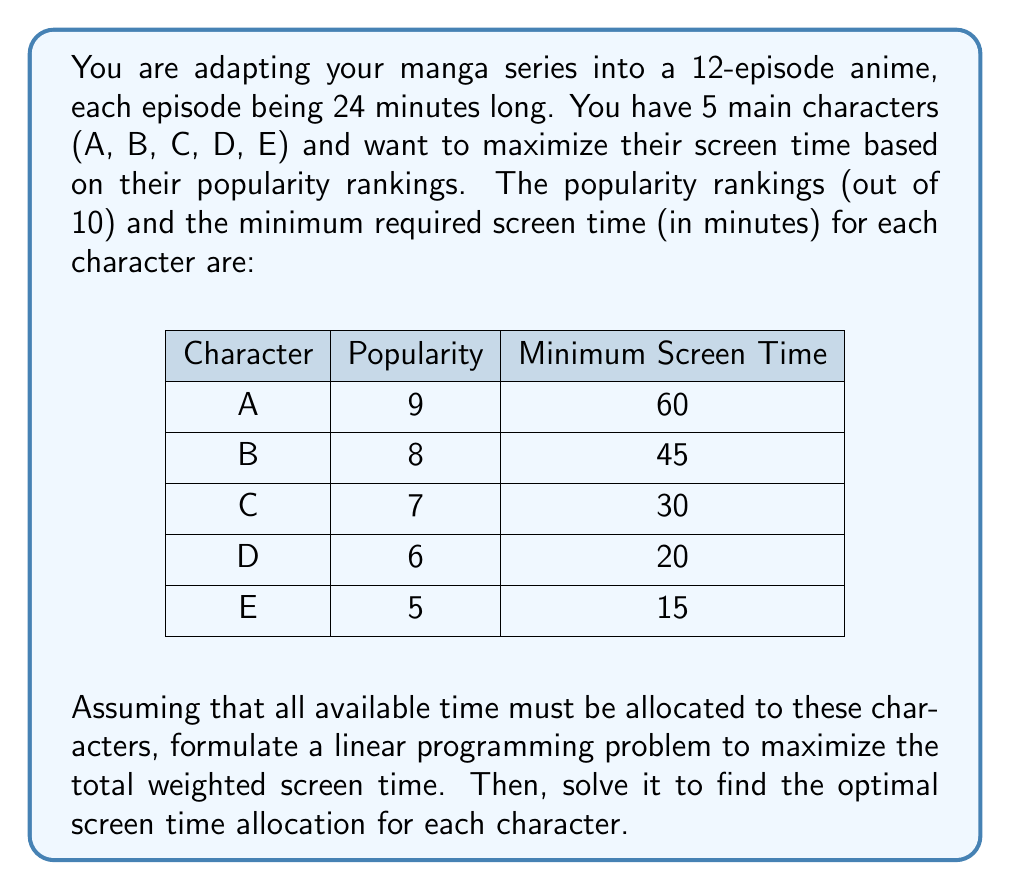Can you solve this math problem? To solve this problem, we'll use linear programming. Let's define our variables and constraints:

Variables:
$x_A, x_B, x_C, x_D, x_E$ = screen time for characters A, B, C, D, and E respectively

Objective function:
Maximize $Z = 9x_A + 8x_B + 7x_C + 6x_D + 5x_E$

Constraints:
1. Total available time: $x_A + x_B + x_C + x_D + x_E = 12 \cdot 24 = 288$ minutes
2. Minimum screen time for each character:
   $x_A \geq 60$
   $x_B \geq 45$
   $x_C \geq 30$
   $x_D \geq 20$
   $x_E \geq 15$
3. Non-negativity: $x_A, x_B, x_C, x_D, x_E \geq 0$

To solve this, we'll use the simplex method:

1. Convert to standard form:
   Maximize $Z = 9x_A + 8x_B + 7x_C + 6x_D + 5x_E$
   Subject to:
   $x_A + x_B + x_C + x_D + x_E = 288$
   $x_A - s_A = 60$
   $x_B - s_B = 45$
   $x_C - s_C = 30$
   $x_D - s_D = 20$
   $x_E - s_E = 15$
   All variables $\geq 0$

2. Initial basic feasible solution:
   $x_A = 60, x_B = 45, x_C = 30, x_D = 20, x_E = 15, s_A = 0, s_B = 0, s_C = 0, s_D = 0, s_E = 0$
   Slack in total time: $288 - (60 + 45 + 30 + 20 + 15) = 118$

3. Optimize:
   The highest coefficient in the objective function is 9 for $x_A$, so we increase $x_A$.
   $x_A$ can be increased by 118 minutes before hitting the total time constraint.

4. Final solution:
   $x_A = 60 + 118 = 178$
   $x_B = 45$
   $x_C = 30$
   $x_D = 20$
   $x_E = 15$

This solution is optimal because we've allocated all available time and any increase in other variables would decrease the objective function value.
Answer: The optimal screen time allocation is:
Character A: 178 minutes
Character B: 45 minutes
Character C: 30 minutes
Character D: 20 minutes
Character E: 15 minutes 